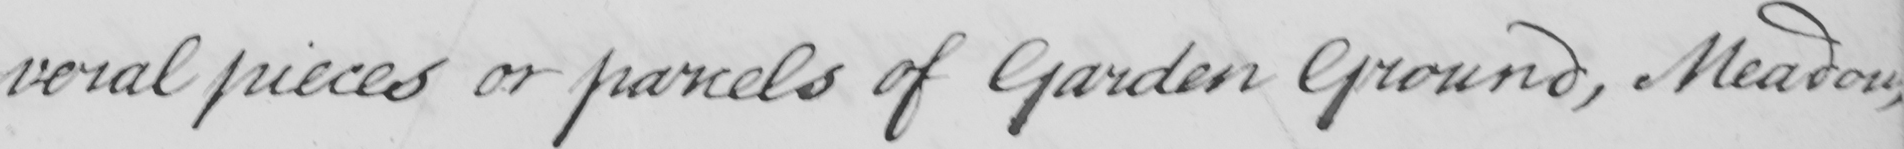What does this handwritten line say? -veral pieces or parcels of Garden Ground , Meadow , 